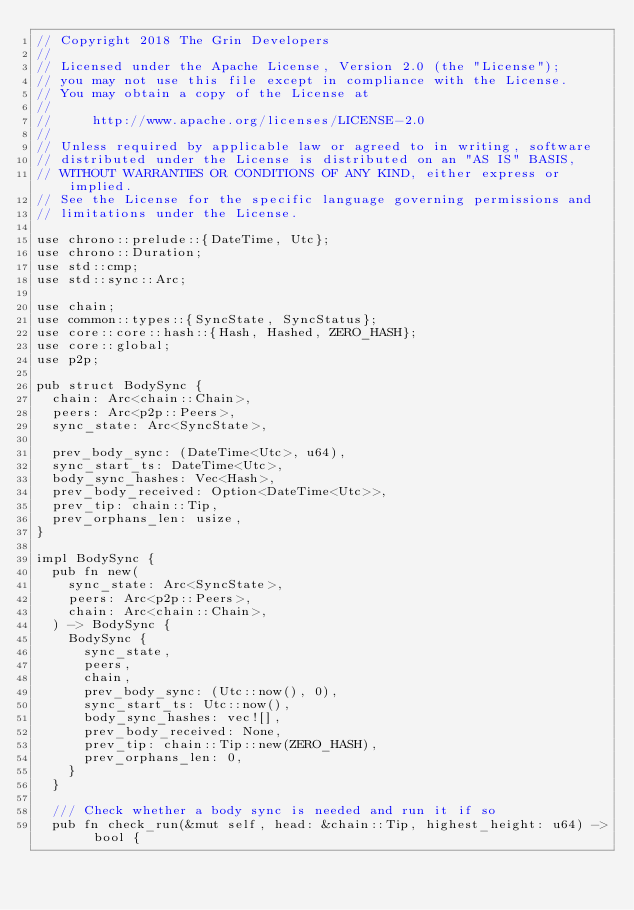Convert code to text. <code><loc_0><loc_0><loc_500><loc_500><_Rust_>// Copyright 2018 The Grin Developers
//
// Licensed under the Apache License, Version 2.0 (the "License");
// you may not use this file except in compliance with the License.
// You may obtain a copy of the License at
//
//     http://www.apache.org/licenses/LICENSE-2.0
//
// Unless required by applicable law or agreed to in writing, software
// distributed under the License is distributed on an "AS IS" BASIS,
// WITHOUT WARRANTIES OR CONDITIONS OF ANY KIND, either express or implied.
// See the License for the specific language governing permissions and
// limitations under the License.

use chrono::prelude::{DateTime, Utc};
use chrono::Duration;
use std::cmp;
use std::sync::Arc;

use chain;
use common::types::{SyncState, SyncStatus};
use core::core::hash::{Hash, Hashed, ZERO_HASH};
use core::global;
use p2p;

pub struct BodySync {
	chain: Arc<chain::Chain>,
	peers: Arc<p2p::Peers>,
	sync_state: Arc<SyncState>,

	prev_body_sync: (DateTime<Utc>, u64),
	sync_start_ts: DateTime<Utc>,
	body_sync_hashes: Vec<Hash>,
	prev_body_received: Option<DateTime<Utc>>,
	prev_tip: chain::Tip,
	prev_orphans_len: usize,
}

impl BodySync {
	pub fn new(
		sync_state: Arc<SyncState>,
		peers: Arc<p2p::Peers>,
		chain: Arc<chain::Chain>,
	) -> BodySync {
		BodySync {
			sync_state,
			peers,
			chain,
			prev_body_sync: (Utc::now(), 0),
			sync_start_ts: Utc::now(),
			body_sync_hashes: vec![],
			prev_body_received: None,
			prev_tip: chain::Tip::new(ZERO_HASH),
			prev_orphans_len: 0,
		}
	}

	/// Check whether a body sync is needed and run it if so
	pub fn check_run(&mut self, head: &chain::Tip, highest_height: u64) -> bool {</code> 